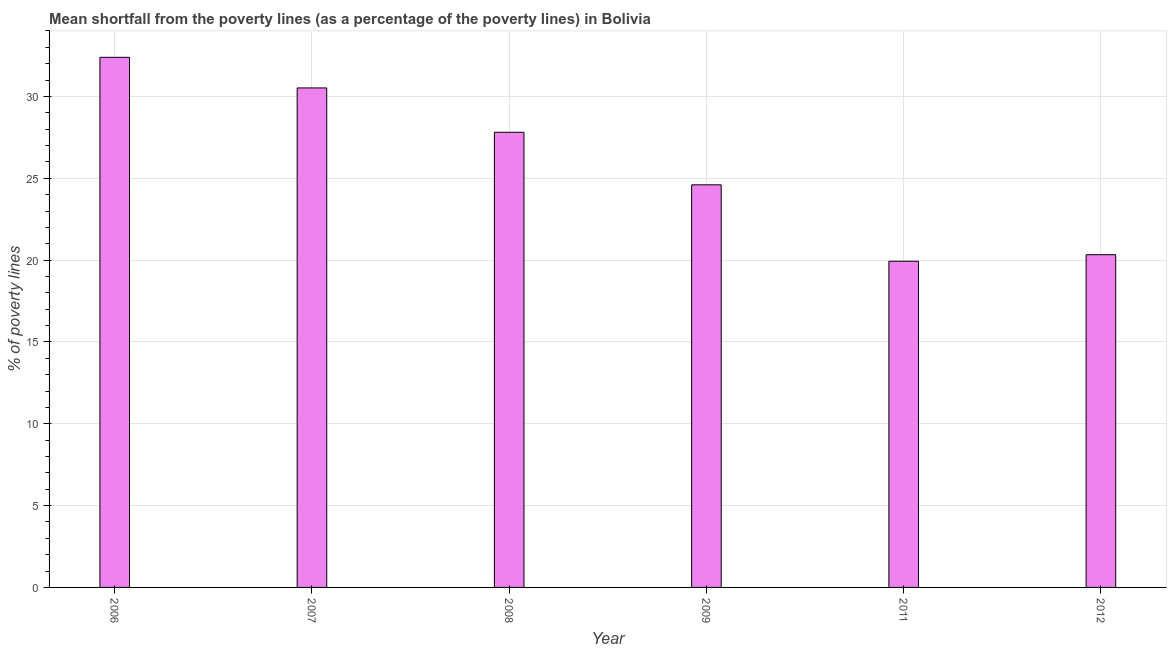What is the title of the graph?
Provide a succinct answer. Mean shortfall from the poverty lines (as a percentage of the poverty lines) in Bolivia. What is the label or title of the X-axis?
Keep it short and to the point. Year. What is the label or title of the Y-axis?
Give a very brief answer. % of poverty lines. What is the poverty gap at national poverty lines in 2007?
Make the answer very short. 30.52. Across all years, what is the maximum poverty gap at national poverty lines?
Provide a short and direct response. 32.39. Across all years, what is the minimum poverty gap at national poverty lines?
Your answer should be compact. 19.93. In which year was the poverty gap at national poverty lines minimum?
Keep it short and to the point. 2011. What is the sum of the poverty gap at national poverty lines?
Your answer should be very brief. 155.58. What is the difference between the poverty gap at national poverty lines in 2009 and 2012?
Your answer should be very brief. 4.27. What is the average poverty gap at national poverty lines per year?
Provide a succinct answer. 25.93. What is the median poverty gap at national poverty lines?
Make the answer very short. 26.2. What is the ratio of the poverty gap at national poverty lines in 2007 to that in 2008?
Offer a terse response. 1.1. Is the difference between the poverty gap at national poverty lines in 2008 and 2011 greater than the difference between any two years?
Your answer should be compact. No. What is the difference between the highest and the second highest poverty gap at national poverty lines?
Make the answer very short. 1.87. What is the difference between the highest and the lowest poverty gap at national poverty lines?
Make the answer very short. 12.46. In how many years, is the poverty gap at national poverty lines greater than the average poverty gap at national poverty lines taken over all years?
Offer a very short reply. 3. What is the % of poverty lines in 2006?
Provide a succinct answer. 32.39. What is the % of poverty lines of 2007?
Give a very brief answer. 30.52. What is the % of poverty lines in 2008?
Keep it short and to the point. 27.81. What is the % of poverty lines in 2009?
Provide a short and direct response. 24.6. What is the % of poverty lines in 2011?
Provide a succinct answer. 19.93. What is the % of poverty lines in 2012?
Give a very brief answer. 20.33. What is the difference between the % of poverty lines in 2006 and 2007?
Keep it short and to the point. 1.87. What is the difference between the % of poverty lines in 2006 and 2008?
Ensure brevity in your answer.  4.58. What is the difference between the % of poverty lines in 2006 and 2009?
Your response must be concise. 7.79. What is the difference between the % of poverty lines in 2006 and 2011?
Keep it short and to the point. 12.46. What is the difference between the % of poverty lines in 2006 and 2012?
Provide a succinct answer. 12.06. What is the difference between the % of poverty lines in 2007 and 2008?
Provide a short and direct response. 2.71. What is the difference between the % of poverty lines in 2007 and 2009?
Offer a terse response. 5.92. What is the difference between the % of poverty lines in 2007 and 2011?
Offer a terse response. 10.59. What is the difference between the % of poverty lines in 2007 and 2012?
Provide a succinct answer. 10.19. What is the difference between the % of poverty lines in 2008 and 2009?
Ensure brevity in your answer.  3.21. What is the difference between the % of poverty lines in 2008 and 2011?
Make the answer very short. 7.88. What is the difference between the % of poverty lines in 2008 and 2012?
Give a very brief answer. 7.48. What is the difference between the % of poverty lines in 2009 and 2011?
Your answer should be compact. 4.67. What is the difference between the % of poverty lines in 2009 and 2012?
Provide a short and direct response. 4.27. What is the ratio of the % of poverty lines in 2006 to that in 2007?
Offer a terse response. 1.06. What is the ratio of the % of poverty lines in 2006 to that in 2008?
Provide a succinct answer. 1.17. What is the ratio of the % of poverty lines in 2006 to that in 2009?
Your response must be concise. 1.32. What is the ratio of the % of poverty lines in 2006 to that in 2011?
Your answer should be compact. 1.62. What is the ratio of the % of poverty lines in 2006 to that in 2012?
Make the answer very short. 1.59. What is the ratio of the % of poverty lines in 2007 to that in 2008?
Your answer should be compact. 1.1. What is the ratio of the % of poverty lines in 2007 to that in 2009?
Offer a very short reply. 1.24. What is the ratio of the % of poverty lines in 2007 to that in 2011?
Offer a terse response. 1.53. What is the ratio of the % of poverty lines in 2007 to that in 2012?
Offer a terse response. 1.5. What is the ratio of the % of poverty lines in 2008 to that in 2009?
Your answer should be compact. 1.13. What is the ratio of the % of poverty lines in 2008 to that in 2011?
Give a very brief answer. 1.4. What is the ratio of the % of poverty lines in 2008 to that in 2012?
Your answer should be compact. 1.37. What is the ratio of the % of poverty lines in 2009 to that in 2011?
Provide a succinct answer. 1.23. What is the ratio of the % of poverty lines in 2009 to that in 2012?
Ensure brevity in your answer.  1.21. 